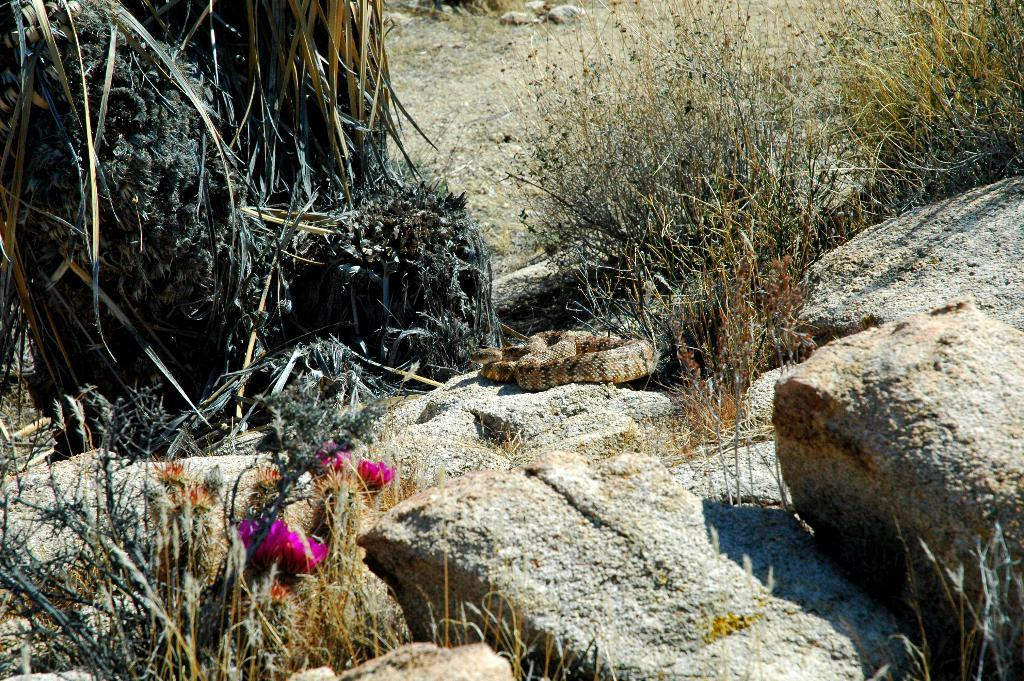What type of animal can be seen on the rocks in the image? There is a snake on the rocks in the image. What kind of vegetation is present in the image? There are flower plants and trees in the image. Can you describe any other elements in the image? There are other unspecified elements in the image. What type of cloth is being used by the society in the image? There is no reference to a society or cloth in the image, so it is not possible to answer that question. 